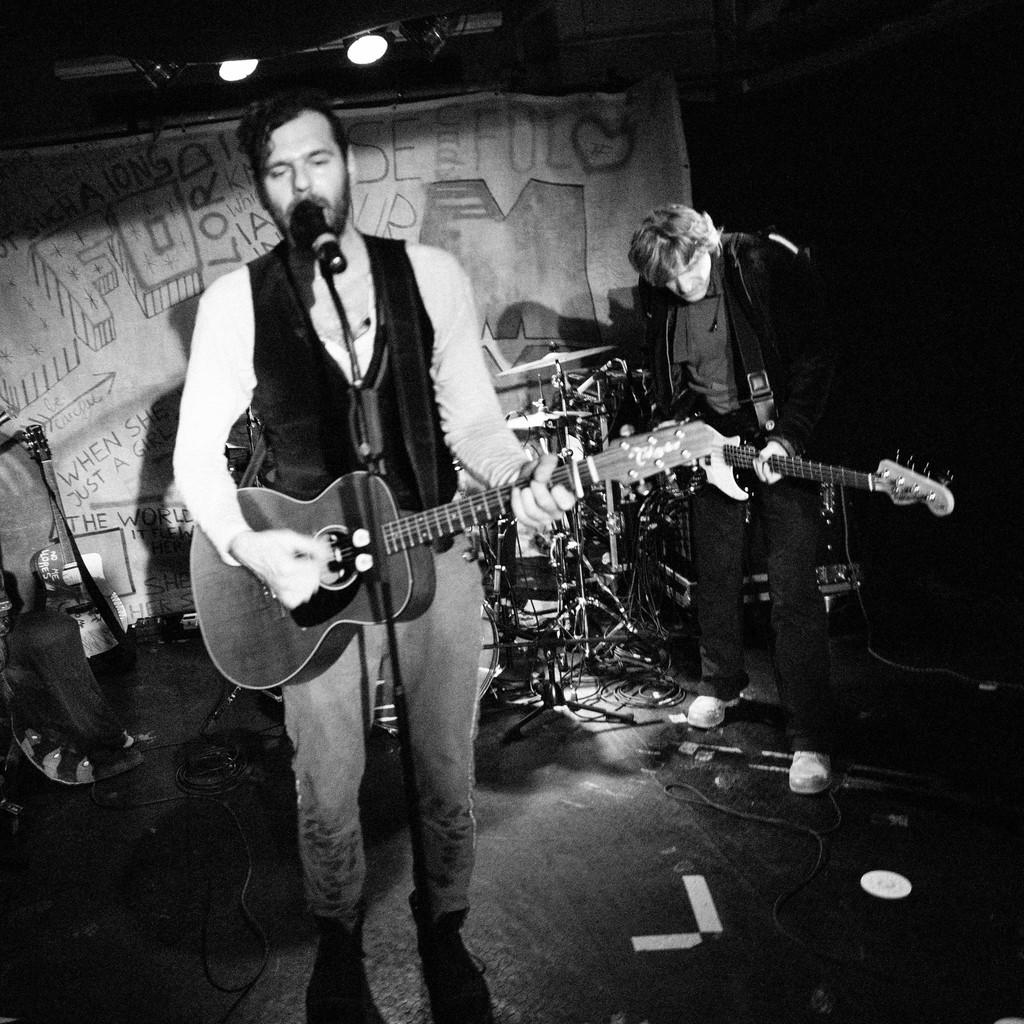What is the color scheme of the image? The image is black and white. How many people are in the image? There are two men in the image. What are the men doing in the image? The men are standing and playing guitar. What object is present for amplifying sound? There is a microphone (mike) in the image. What is the men standing on in the image? There is a platform in the image. What can be seen at the top of the image? Lights are visible at the top of the image. How many girls are playing the guitar in the image? There are no girls present in the image; it features two men playing guitar. What type of bottle is placed next to the microphone? There is no bottle present in the image; it only features a microphone, two men playing guitar, a platform, and lights. 